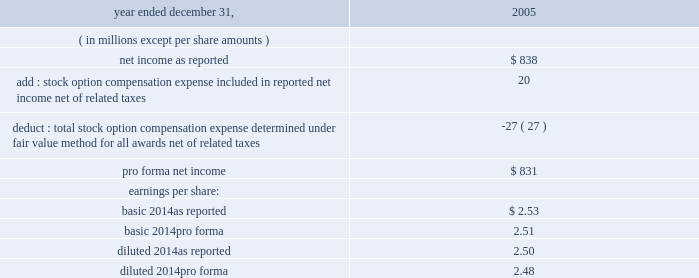The table illustrates the pro forma effect on net income and earnings per share as if all outstanding and unvested stock options in 2005 were accounted for using estimated fair value .
2005year ended december 31 .
Basic earnings per share is calculated by dividing net income available to common shareholders by the weighted-average number of common shares outstanding for the period , which excludes unvested shares of restricted stock .
Diluted earnings per share is calculated by dividing net income available to common shareholders by the weighted-average number of common shares outstanding for the period and the shares representing the dilutive effect of stock options and awards and other equity-related financial instruments .
The effect of stock options and restricted stock outstanding is excluded from the calculation of diluted earnings per share in periods in which their effect would be antidilutive .
Special purpose entities : we are involved with various legal forms of special purpose entities , or spes , in the normal course of our business .
We use trusts to structure and sell certificated interests in pools of tax-exempt investment-grade assets principally to our mutual fund customers .
These trusts are recorded in our consolidated financial statements .
We transfer assets to these trusts , which are legally isolated from us , from our investment securities portfolio at adjusted book value .
The trusts finance the acquisition of these assets by selling certificated interests issued by the trusts to third-party investors .
The investment securities of the trusts are carried in investments securities available for sale at fair value .
The certificated interests are carried in other short-term borrowings at the amount owed to the third-party investors .
The interest revenue and interest expense generated by the investments and certificated interests , respectively , are recorded in net interest revenue when earned or incurred. .
What is the number of outstanding shares based on the eps , ( in millions ) ? 
Computations: (838 / 2.53)
Answer: 331.2253. 